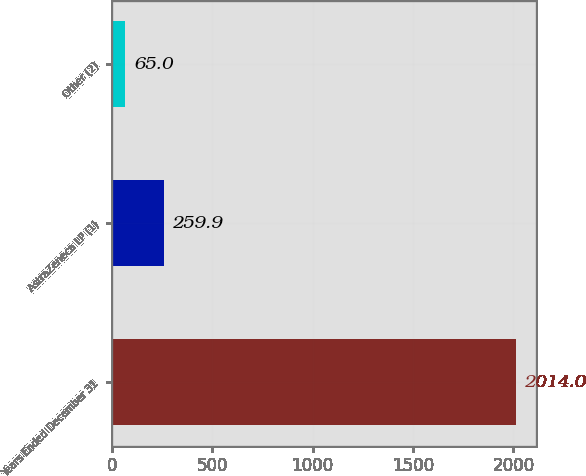<chart> <loc_0><loc_0><loc_500><loc_500><bar_chart><fcel>Years Ended December 31<fcel>AstraZeneca LP (1)<fcel>Other (2)<nl><fcel>2014<fcel>259.9<fcel>65<nl></chart> 